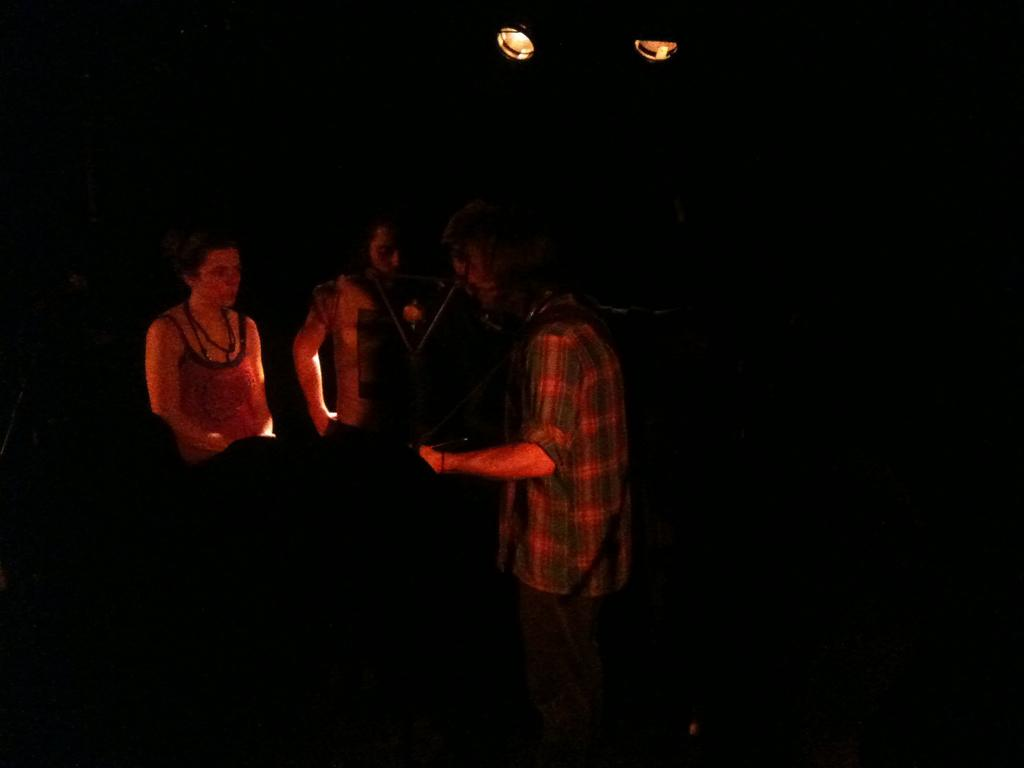What time of day was the image taken? The image was taken during night time. How many people are in the middle of the image? There are three persons in the middle of the image. Can you describe the lighting in the image? There are two lights at the top of the image. What type of milk is being served to the sister in the image? There is no milk or sister present in the image. How does the heat affect the people in the image? The image was taken during night time, so there is no heat mentioned or visible in the image. 